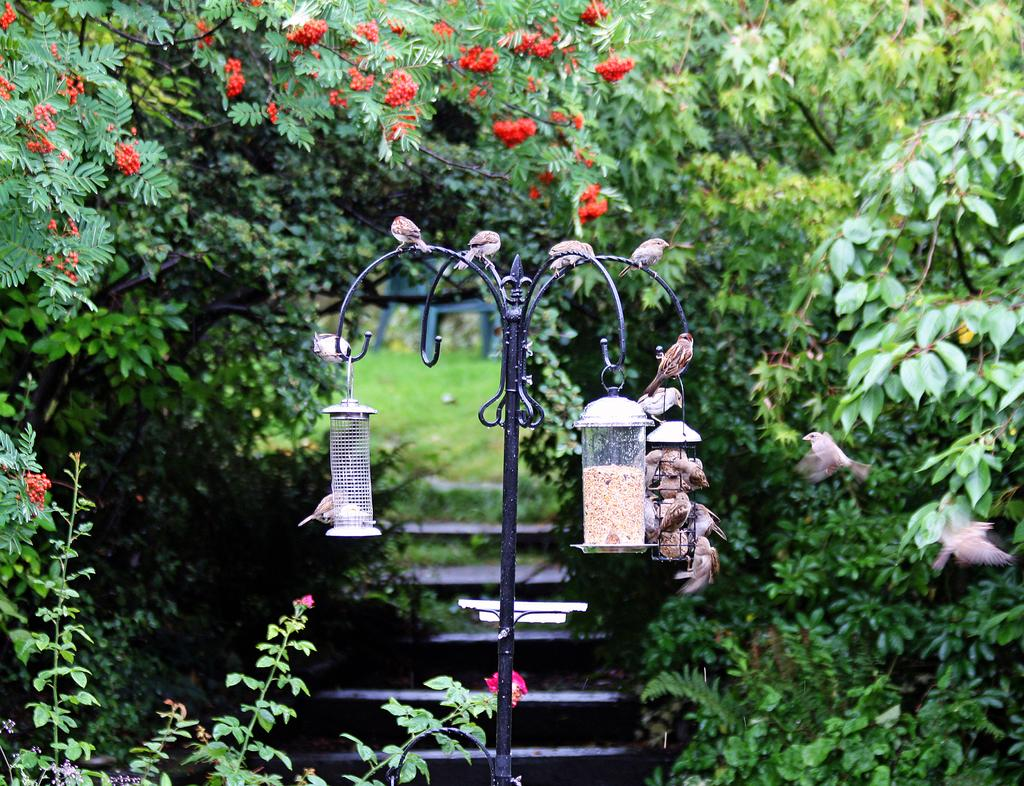What animals are located in the middle of the image? There are birds in the middle of the image. What type of vegetation is on the left side of the image? There are flower trees on the left side of the image. What color are the flower trees? The flower trees are green. What type of ink can be seen dripping from the birds in the image? There is no ink present in the image, and the birds are not depicted as dripping any substance. 